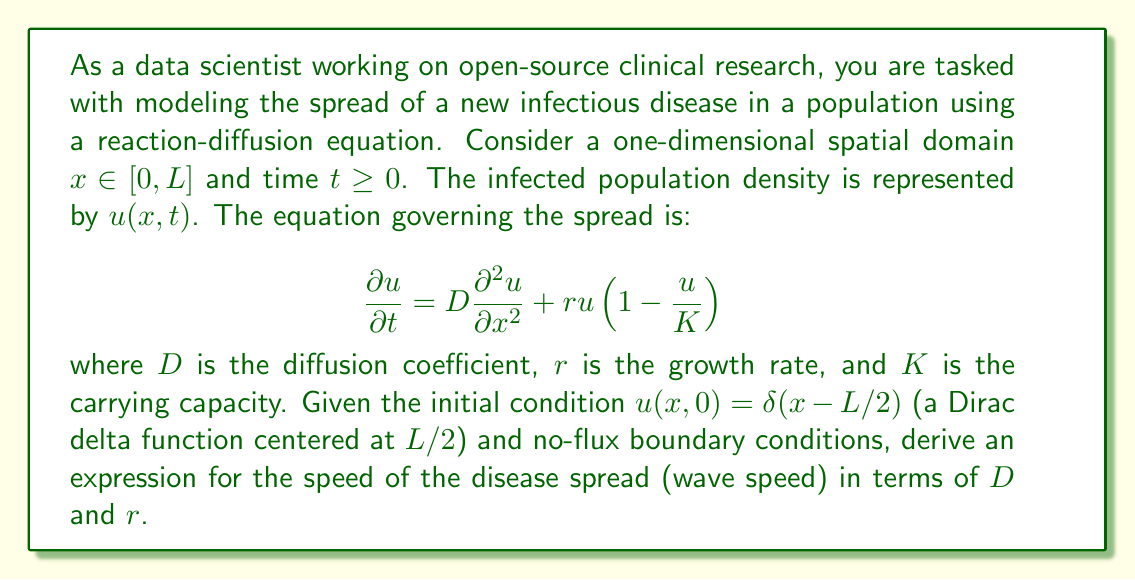Teach me how to tackle this problem. To solve this problem, we'll follow these steps:

1) Recognize the equation as a Fisher-KPP (Kolmogorov-Petrovsky-Piskunov) equation, which is a type of reaction-diffusion equation.

2) For the Fisher-KPP equation, it's known that there exists a traveling wave solution that connects the unstable steady state ($u=0$) to the stable steady state ($u=K$).

3) The wave speed for such a solution can be derived using linear analysis near the leading edge of the wave, where $u$ is small.

4) Near the leading edge, we can approximate the equation as:

   $$\frac{\partial u}{\partial t} \approx D\frac{\partial^2 u}{\partial x^2} + ru$$

5) We look for solutions of the form $u(x,t) = e^{-\lambda(x-ct)}$, where $c$ is the wave speed we're trying to find.

6) Substituting this into our linearized equation:

   $$-c\lambda e^{-\lambda(x-ct)} = D\lambda^2 e^{-\lambda(x-ct)} + re^{-\lambda(x-ct)}$$

7) Simplifying:

   $$-c\lambda = D\lambda^2 + r$$

8) Rearranging to solve for $c$:

   $$c = -D\lambda - \frac{r}{\lambda}$$

9) The minimum wave speed occurs when $\frac{dc}{d\lambda} = 0$:

   $$\frac{dc}{d\lambda} = -D + \frac{r}{\lambda^2} = 0$$

10) Solving this:

    $$D = \frac{r}{\lambda^2}$$
    $$\lambda = \sqrt{\frac{r}{D}}$$

11) Substituting this back into the expression for $c$:

    $$c = -D\sqrt{\frac{r}{D}} - \frac{r}{\sqrt{\frac{r}{D}}} = -2\sqrt{Dr}$$

12) The negative sign indicates the direction of propagation. The actual speed is the absolute value.

Therefore, the wave speed is $c = 2\sqrt{Dr}$.
Answer: The speed of disease spread (wave speed) is $c = 2\sqrt{Dr}$, where $D$ is the diffusion coefficient and $r$ is the growth rate. 